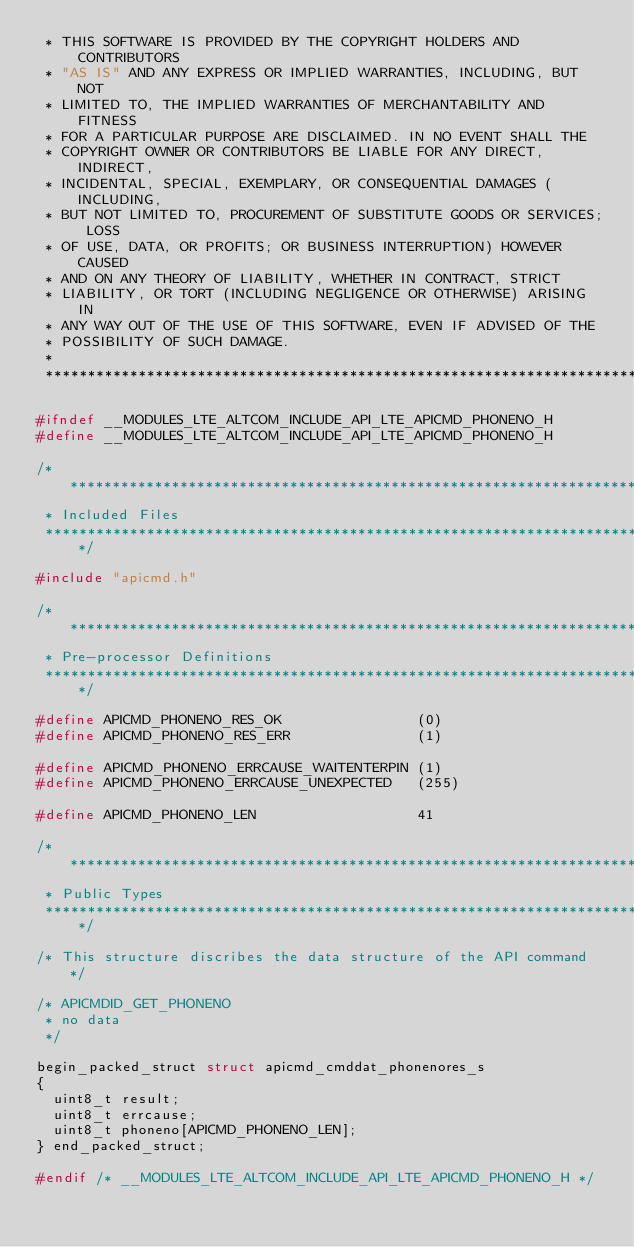Convert code to text. <code><loc_0><loc_0><loc_500><loc_500><_C_> * THIS SOFTWARE IS PROVIDED BY THE COPYRIGHT HOLDERS AND CONTRIBUTORS
 * "AS IS" AND ANY EXPRESS OR IMPLIED WARRANTIES, INCLUDING, BUT NOT
 * LIMITED TO, THE IMPLIED WARRANTIES OF MERCHANTABILITY AND FITNESS
 * FOR A PARTICULAR PURPOSE ARE DISCLAIMED. IN NO EVENT SHALL THE
 * COPYRIGHT OWNER OR CONTRIBUTORS BE LIABLE FOR ANY DIRECT, INDIRECT,
 * INCIDENTAL, SPECIAL, EXEMPLARY, OR CONSEQUENTIAL DAMAGES (INCLUDING,
 * BUT NOT LIMITED TO, PROCUREMENT OF SUBSTITUTE GOODS OR SERVICES; LOSS
 * OF USE, DATA, OR PROFITS; OR BUSINESS INTERRUPTION) HOWEVER CAUSED
 * AND ON ANY THEORY OF LIABILITY, WHETHER IN CONTRACT, STRICT
 * LIABILITY, OR TORT (INCLUDING NEGLIGENCE OR OTHERWISE) ARISING IN
 * ANY WAY OUT OF THE USE OF THIS SOFTWARE, EVEN IF ADVISED OF THE
 * POSSIBILITY OF SUCH DAMAGE.
 *
 ****************************************************************************/

#ifndef __MODULES_LTE_ALTCOM_INCLUDE_API_LTE_APICMD_PHONENO_H
#define __MODULES_LTE_ALTCOM_INCLUDE_API_LTE_APICMD_PHONENO_H

/****************************************************************************
 * Included Files
 ****************************************************************************/

#include "apicmd.h"

/****************************************************************************
 * Pre-processor Definitions
 ****************************************************************************/

#define APICMD_PHONENO_RES_OK                (0)
#define APICMD_PHONENO_RES_ERR               (1)

#define APICMD_PHONENO_ERRCAUSE_WAITENTERPIN (1)
#define APICMD_PHONENO_ERRCAUSE_UNEXPECTED   (255)

#define APICMD_PHONENO_LEN                   41

/****************************************************************************
 * Public Types
 ****************************************************************************/

/* This structure discribes the data structure of the API command */

/* APICMDID_GET_PHONENO
 * no data
 */

begin_packed_struct struct apicmd_cmddat_phonenores_s
{
  uint8_t result;
  uint8_t errcause;
  uint8_t phoneno[APICMD_PHONENO_LEN];
} end_packed_struct;

#endif /* __MODULES_LTE_ALTCOM_INCLUDE_API_LTE_APICMD_PHONENO_H */
</code> 